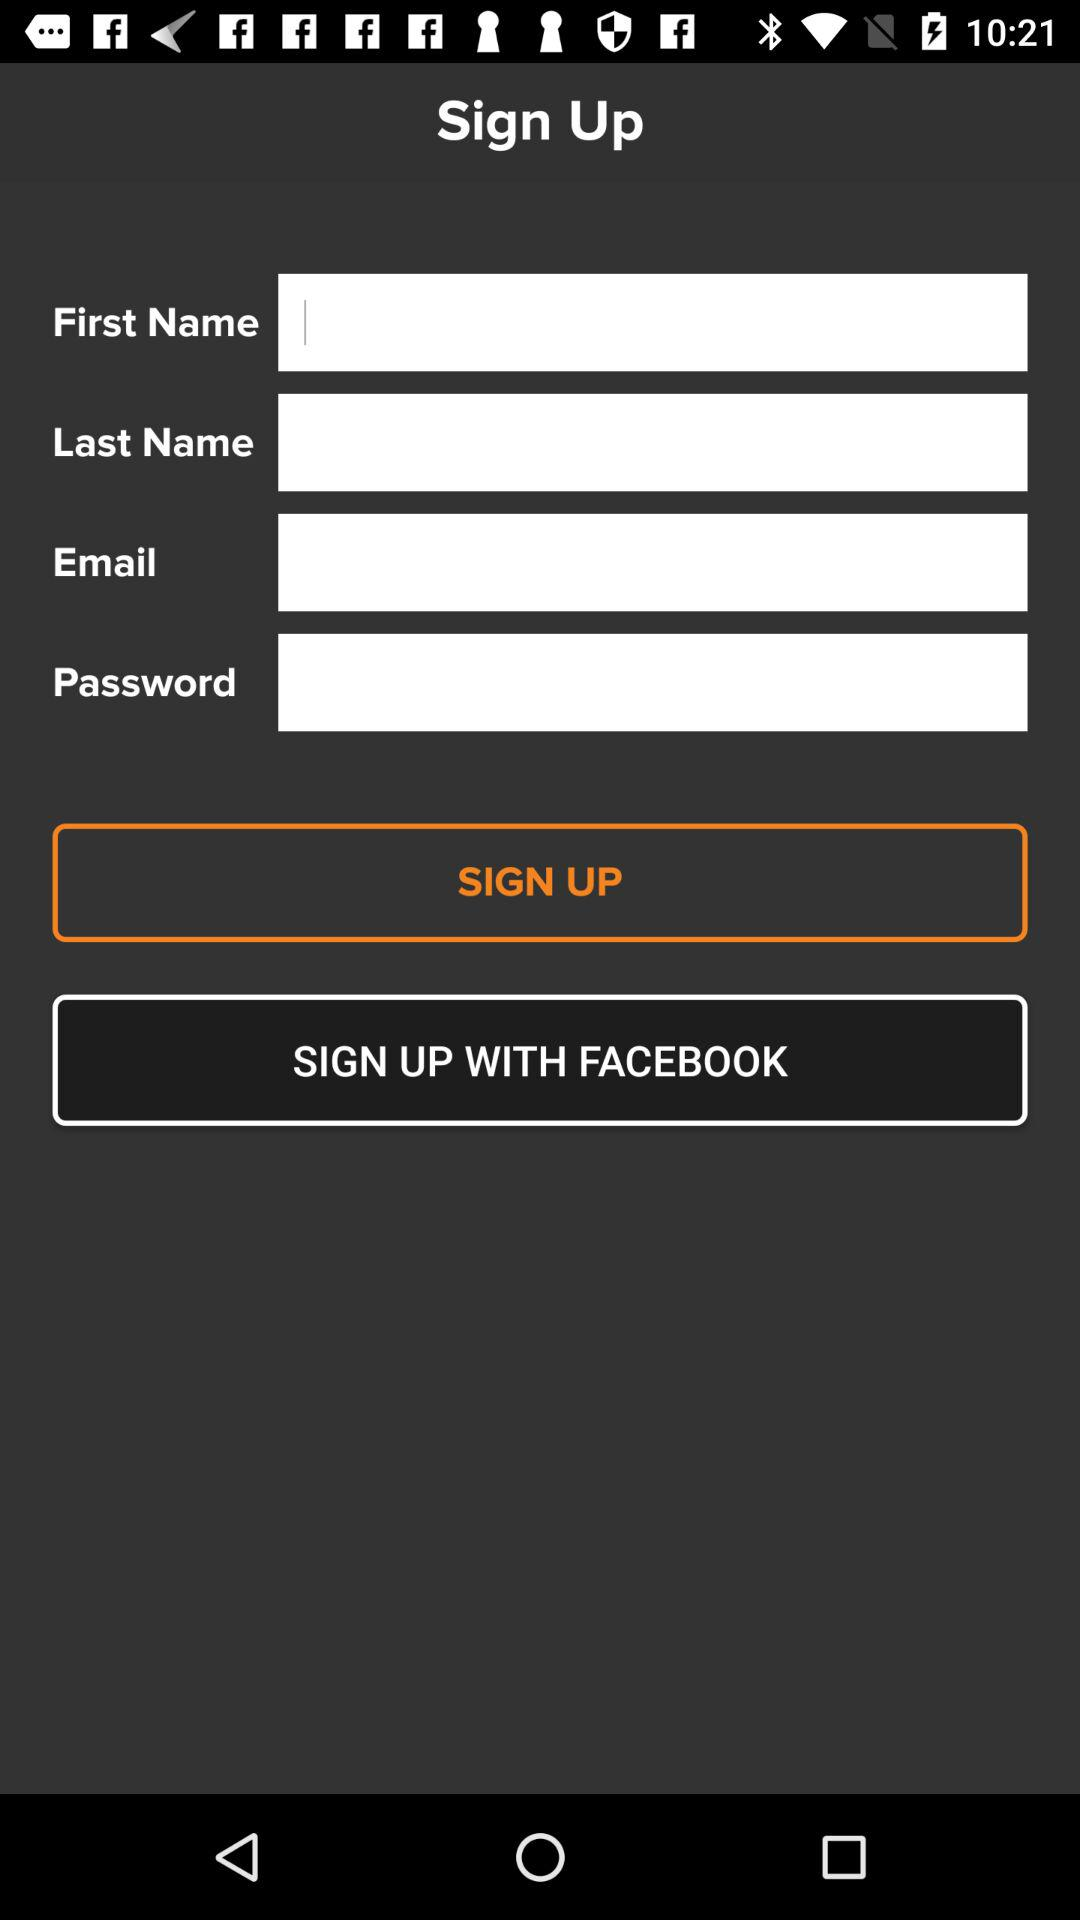What is the other option for signing up? The other option is "FACEBOOK". 